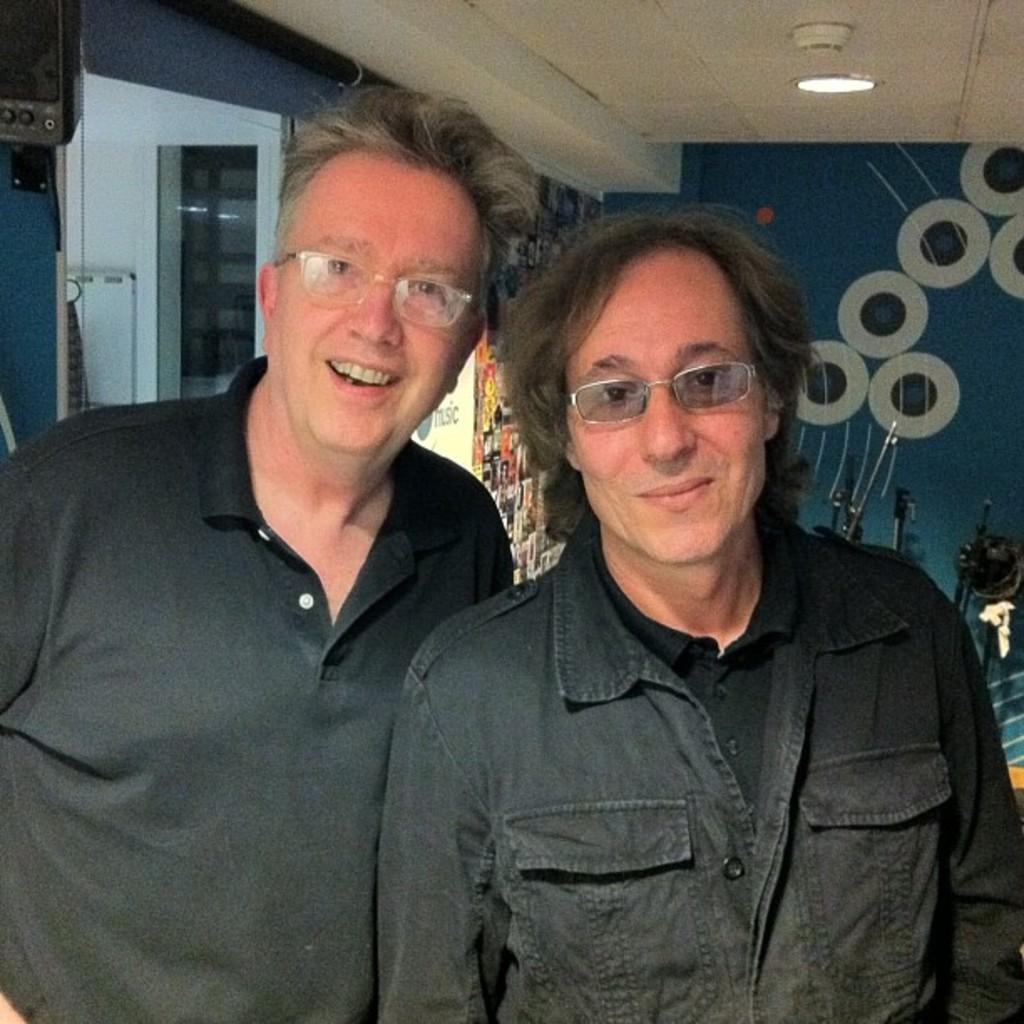How many people are in the image? There are two persons standing in the center of the image. What are the people wearing? Both persons are wearing black color dress. What accessory do both persons have in common? Both persons are wearing spectacles. What can be seen in the background of the image? There is a wall in the background of the image. What is the size of the view that the persons are approving in the image? There is no indication in the image that the persons are approving a view or that there is a specific size associated with it. 